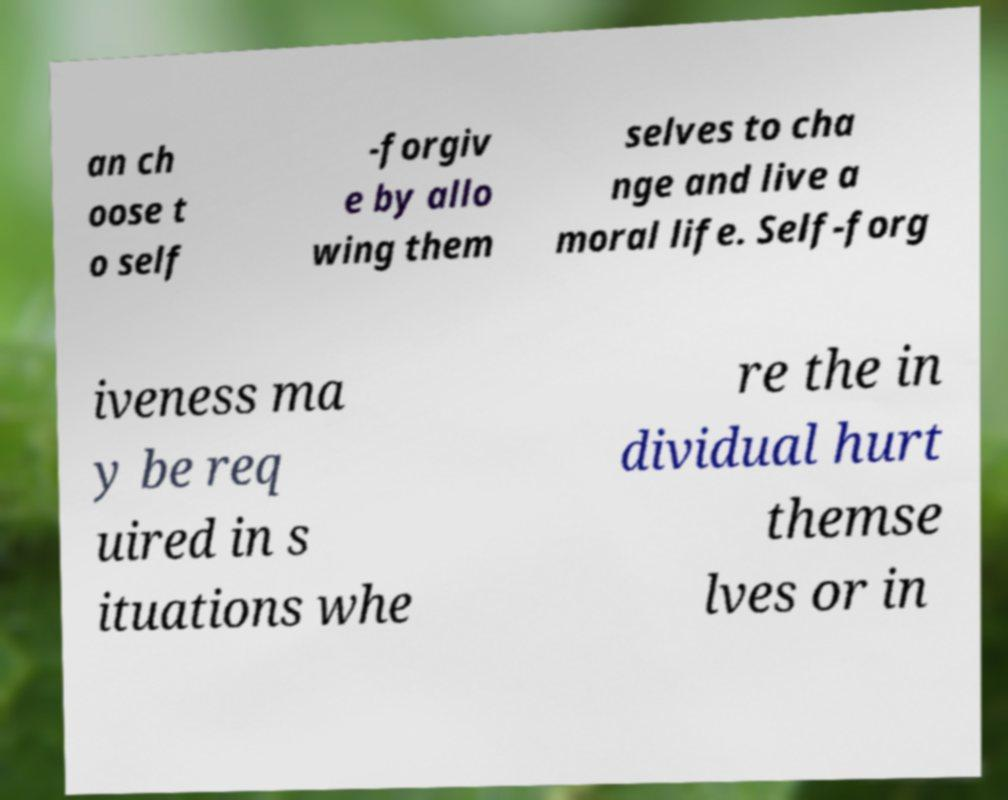There's text embedded in this image that I need extracted. Can you transcribe it verbatim? an ch oose t o self -forgiv e by allo wing them selves to cha nge and live a moral life. Self-forg iveness ma y be req uired in s ituations whe re the in dividual hurt themse lves or in 